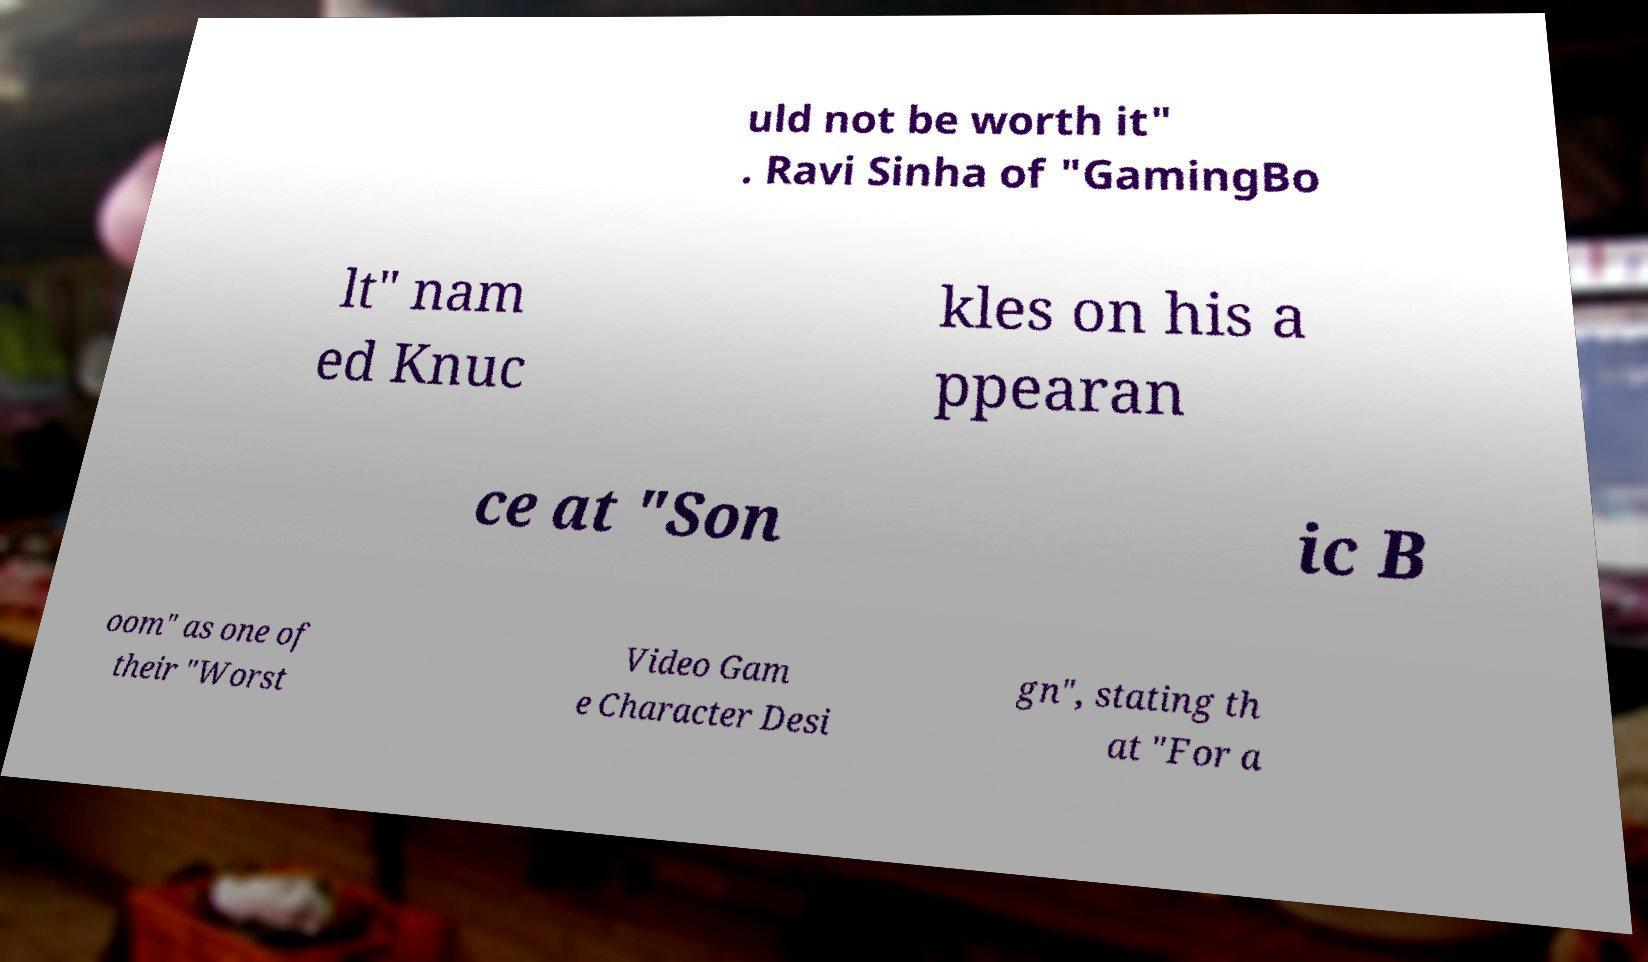There's text embedded in this image that I need extracted. Can you transcribe it verbatim? uld not be worth it" . Ravi Sinha of "GamingBo lt" nam ed Knuc kles on his a ppearan ce at "Son ic B oom" as one of their "Worst Video Gam e Character Desi gn", stating th at "For a 